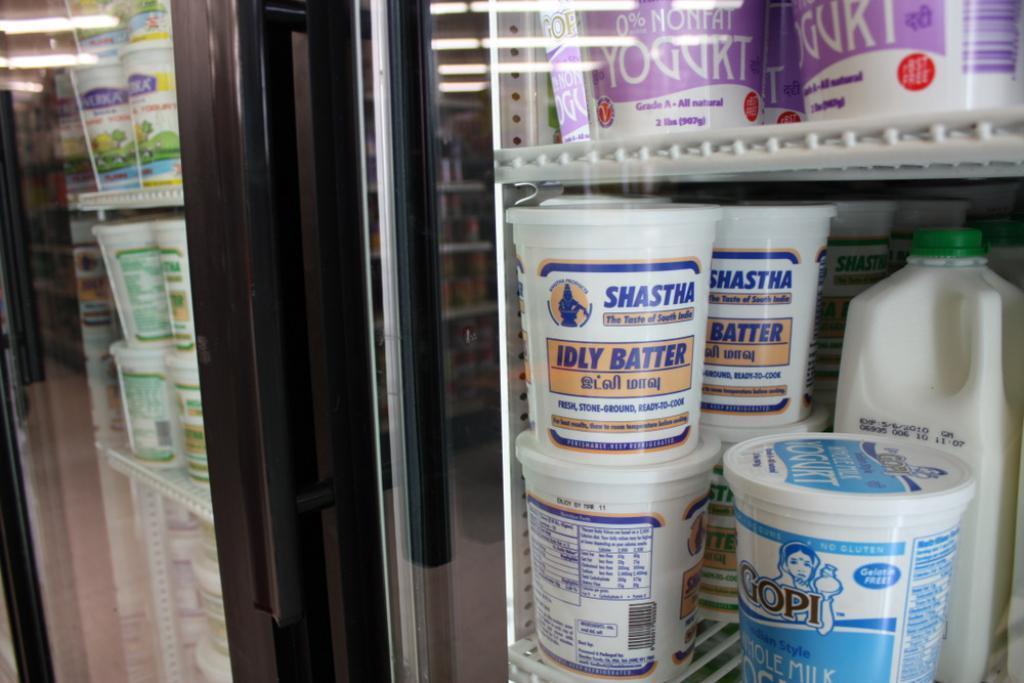Describe this image in one or two sentences. In this image, we can see glass doors. Through the glass doors, we can see few containers, can are placed on a rack. On the glass, we can see some reflections. Few objects, items, lights we can see here. 